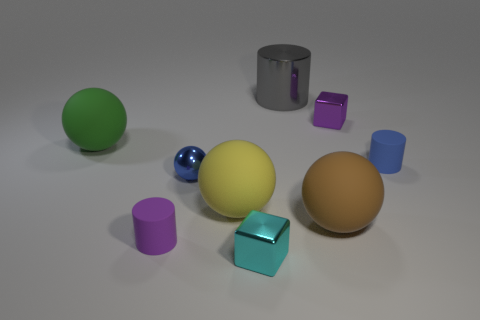Add 1 blue metal objects. How many objects exist? 10 Subtract all cubes. How many objects are left? 7 Subtract all purple blocks. Subtract all large gray things. How many objects are left? 7 Add 8 blue objects. How many blue objects are left? 10 Add 2 rubber cylinders. How many rubber cylinders exist? 4 Subtract 1 purple cylinders. How many objects are left? 8 